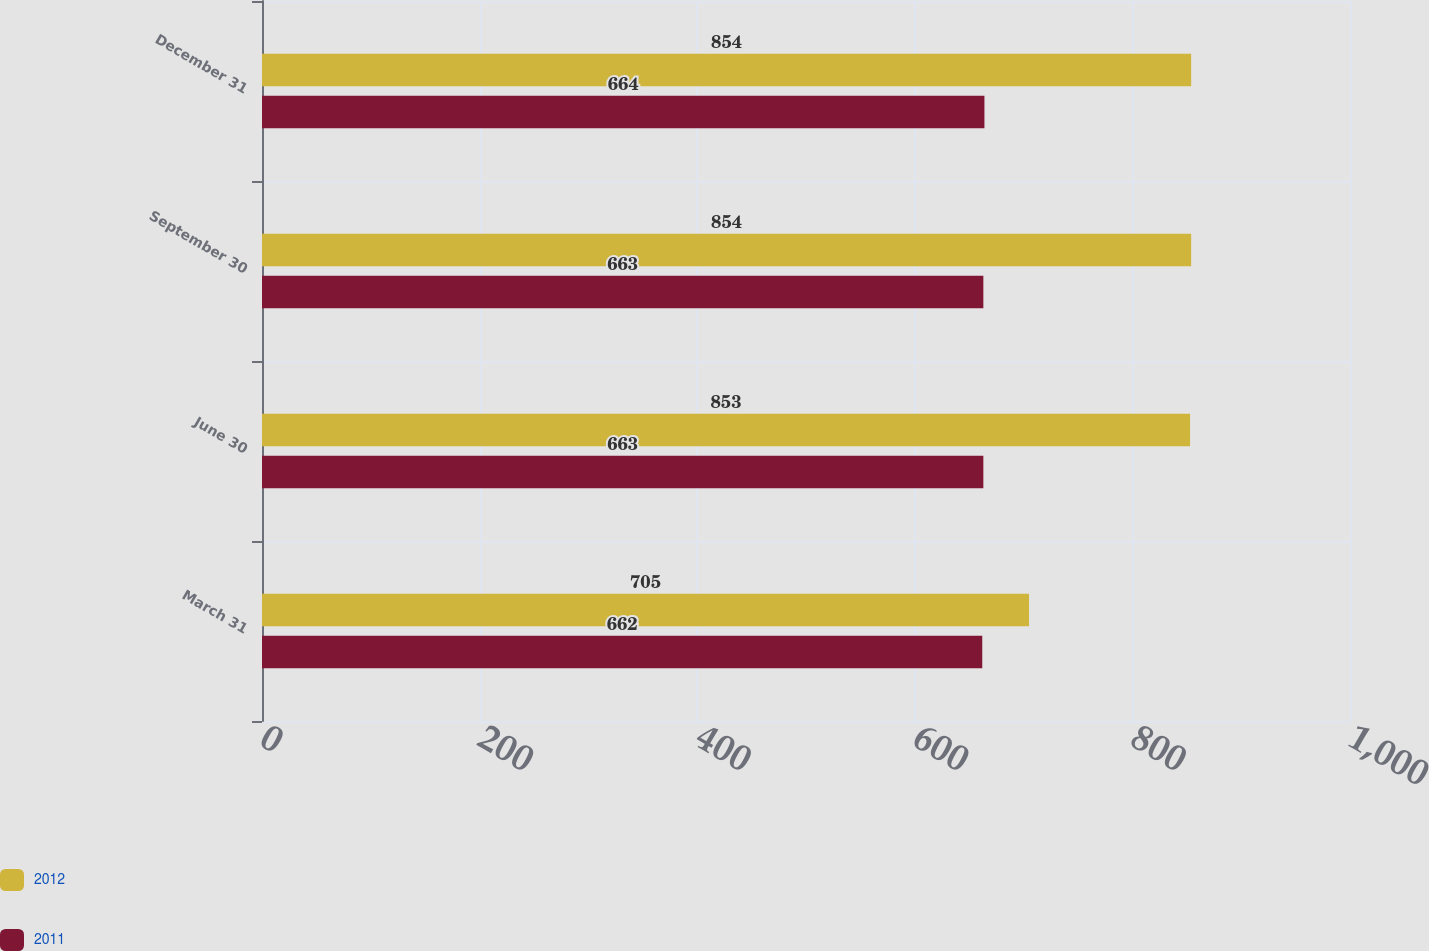<chart> <loc_0><loc_0><loc_500><loc_500><stacked_bar_chart><ecel><fcel>March 31<fcel>June 30<fcel>September 30<fcel>December 31<nl><fcel>2012<fcel>705<fcel>853<fcel>854<fcel>854<nl><fcel>2011<fcel>662<fcel>663<fcel>663<fcel>664<nl></chart> 